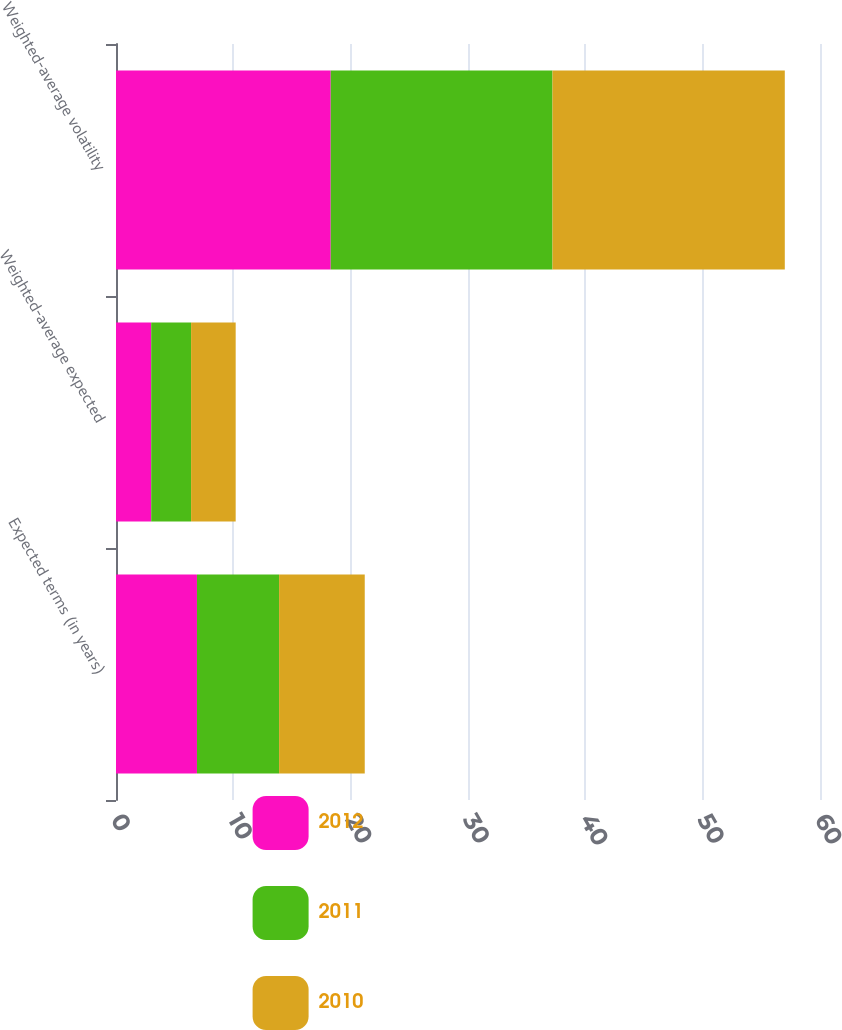<chart> <loc_0><loc_0><loc_500><loc_500><stacked_bar_chart><ecel><fcel>Expected terms (in years)<fcel>Weighted-average expected<fcel>Weighted-average volatility<nl><fcel>2012<fcel>6.9<fcel>3<fcel>18.3<nl><fcel>2011<fcel>7<fcel>3.4<fcel>18.9<nl><fcel>2010<fcel>7.3<fcel>3.8<fcel>19.8<nl></chart> 